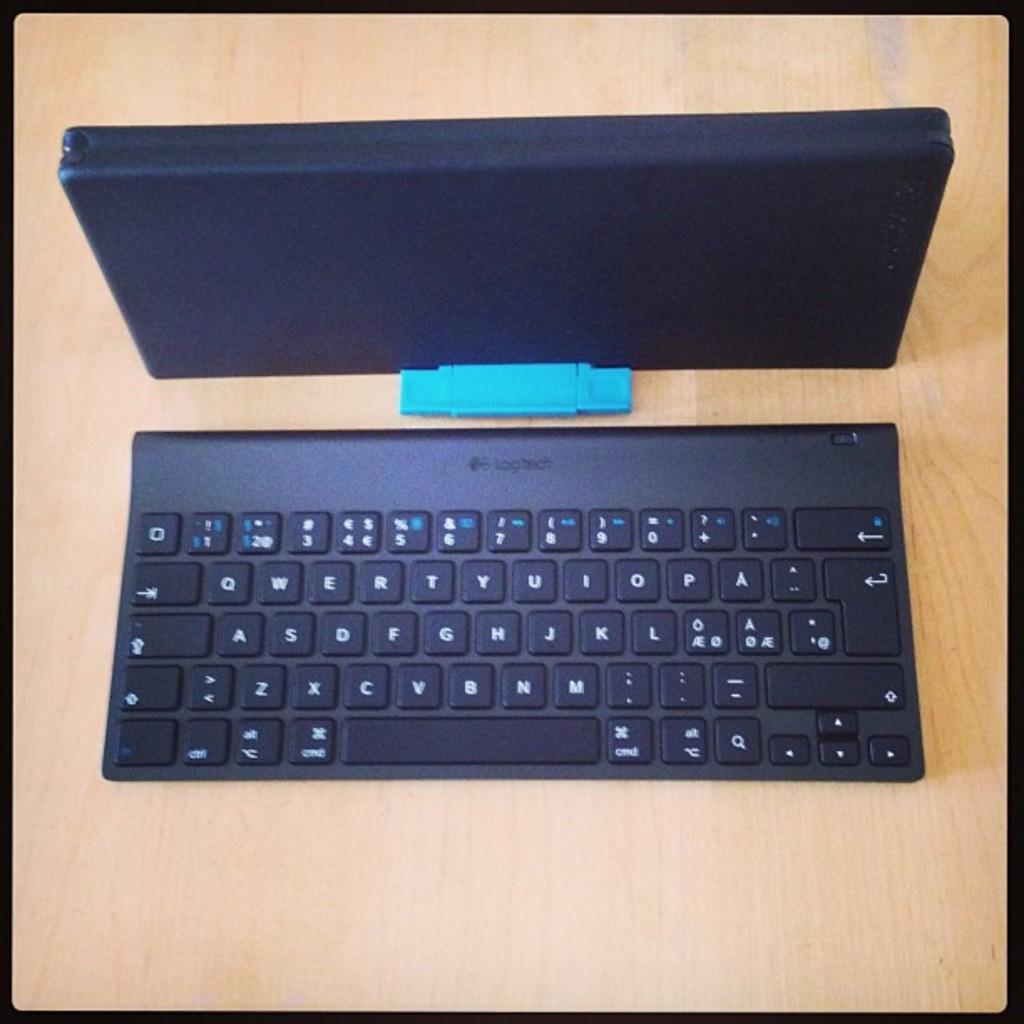What brand is this keyboard?
Give a very brief answer. Logitech. Is logitech the word on top of this keyboard?
Ensure brevity in your answer.  Yes. 